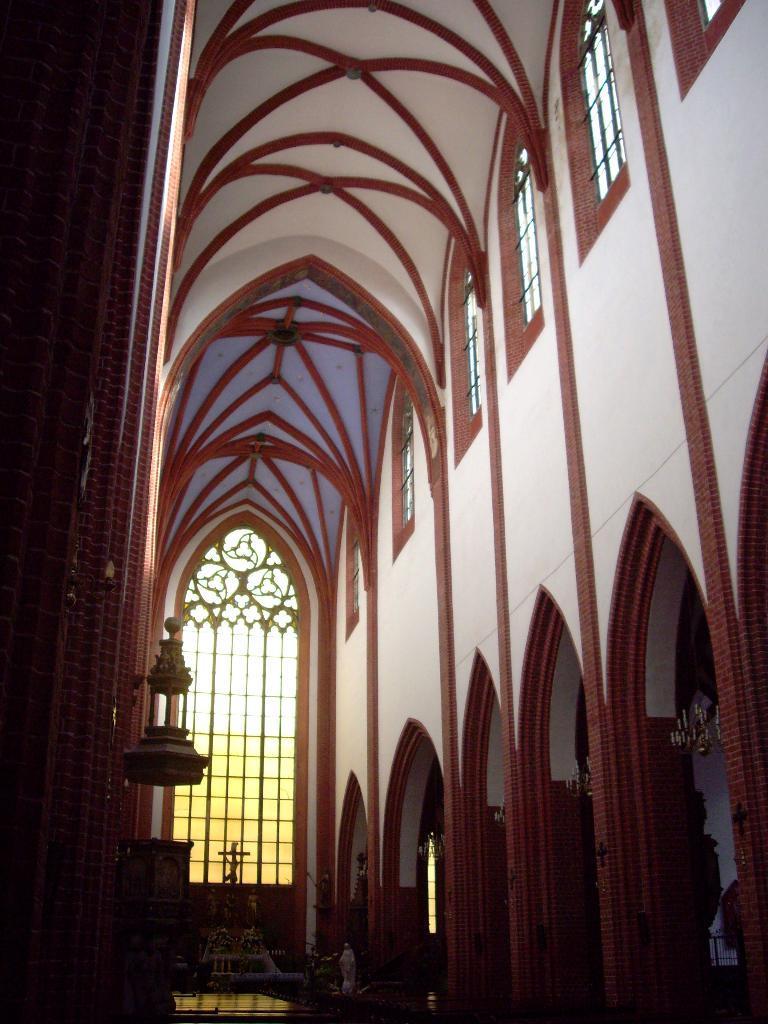Could you give a brief overview of what you see in this image? In the foreground I can see a church wall and a rooftop. This image is taken during a day in a church. 